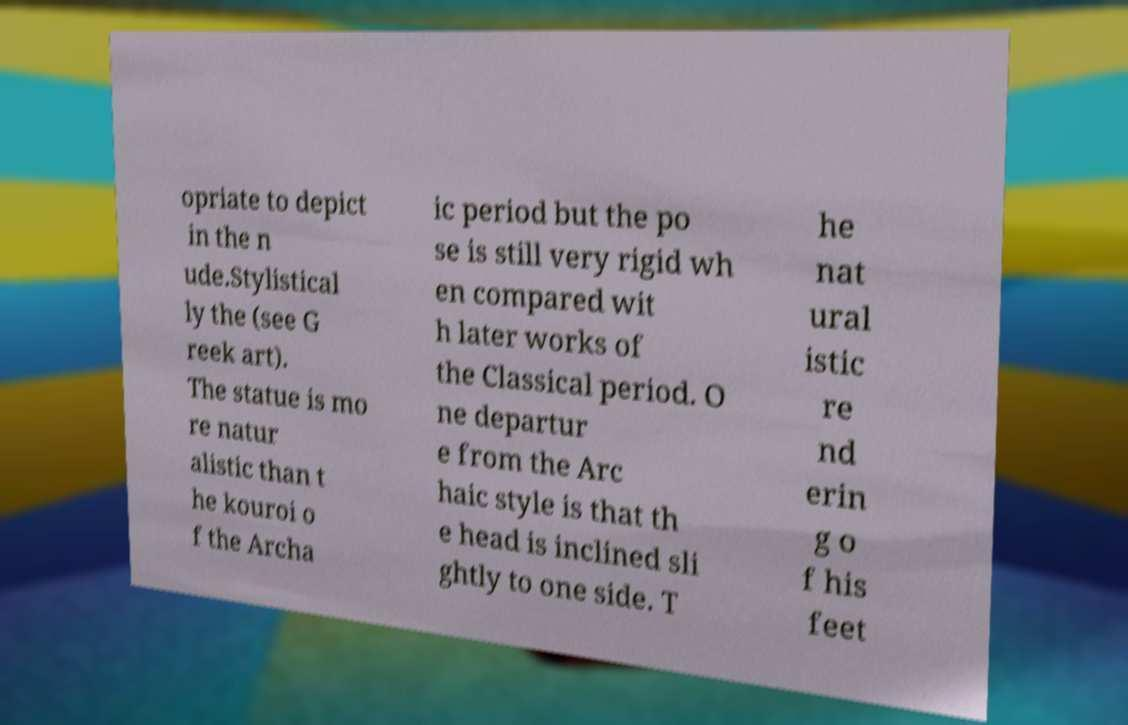There's text embedded in this image that I need extracted. Can you transcribe it verbatim? opriate to depict in the n ude.Stylistical ly the (see G reek art). The statue is mo re natur alistic than t he kouroi o f the Archa ic period but the po se is still very rigid wh en compared wit h later works of the Classical period. O ne departur e from the Arc haic style is that th e head is inclined sli ghtly to one side. T he nat ural istic re nd erin g o f his feet 